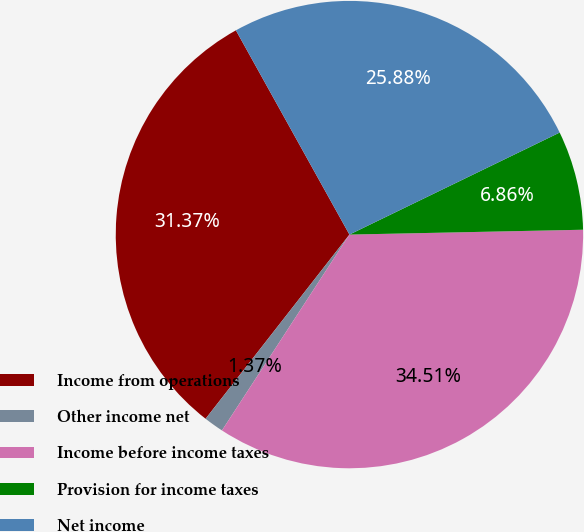<chart> <loc_0><loc_0><loc_500><loc_500><pie_chart><fcel>Income from operations<fcel>Other income net<fcel>Income before income taxes<fcel>Provision for income taxes<fcel>Net income<nl><fcel>31.37%<fcel>1.37%<fcel>34.51%<fcel>6.86%<fcel>25.88%<nl></chart> 